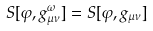<formula> <loc_0><loc_0><loc_500><loc_500>S [ \varphi , g _ { \mu \nu } ^ { \omega } ] = S [ \varphi , g _ { \mu \nu } ]</formula> 